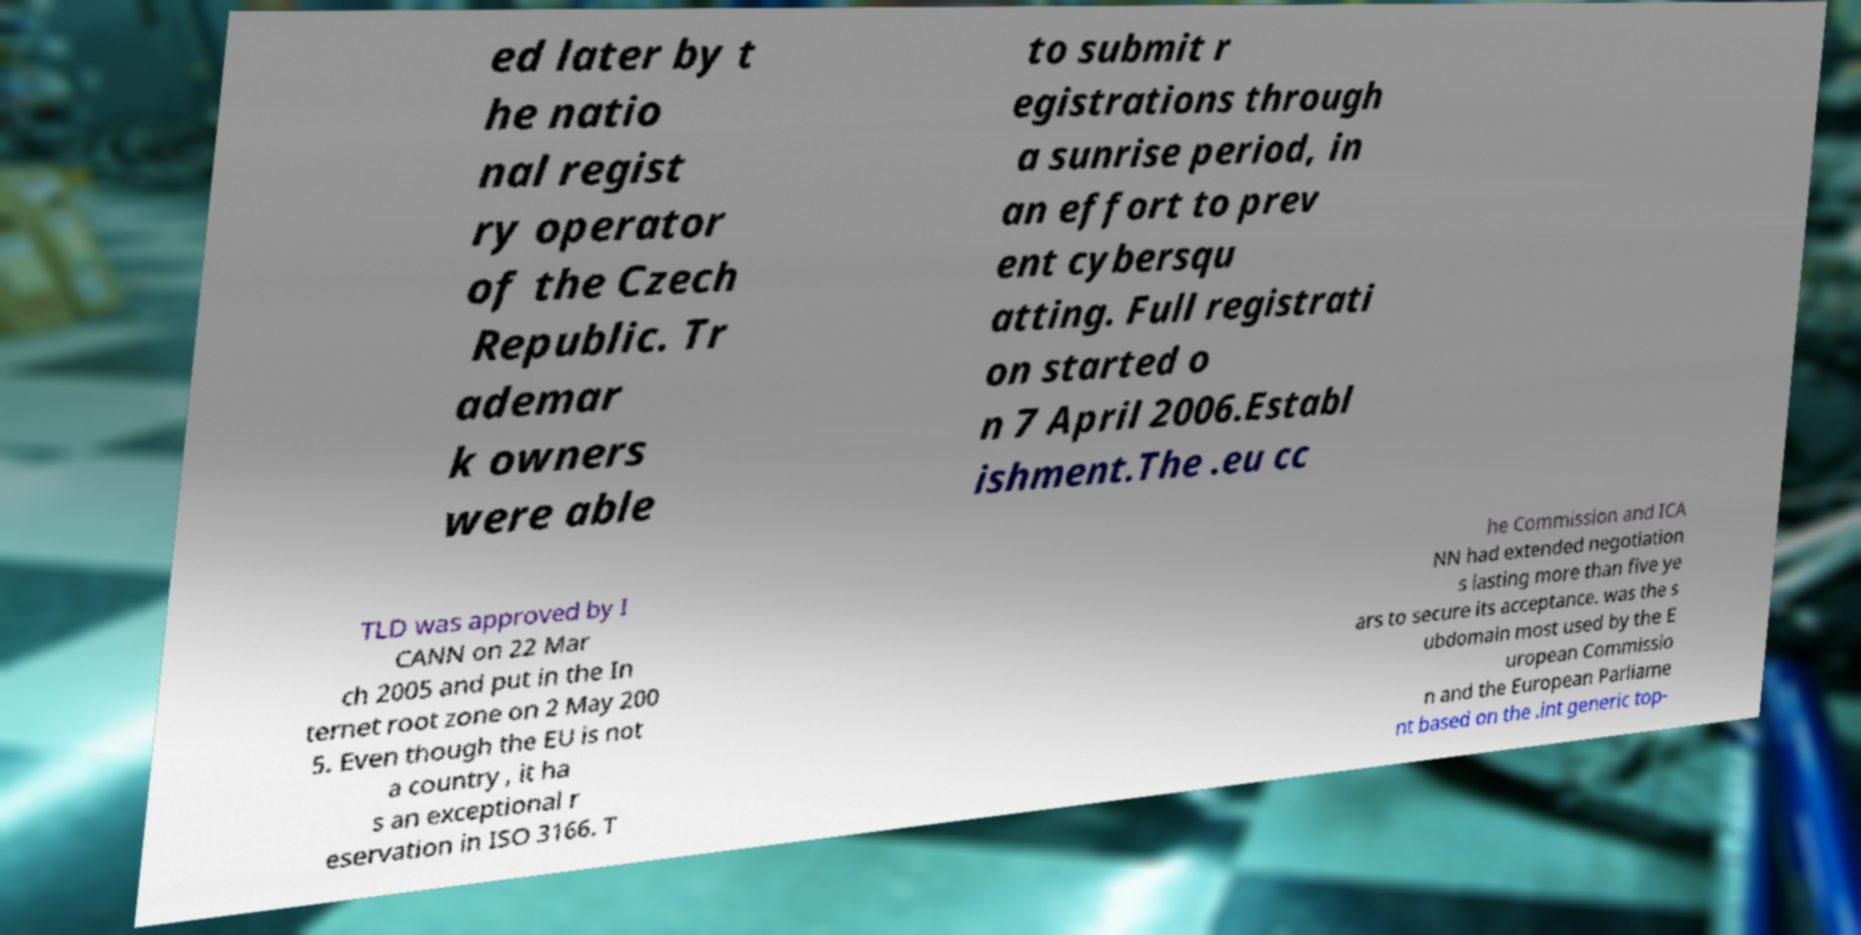I need the written content from this picture converted into text. Can you do that? ed later by t he natio nal regist ry operator of the Czech Republic. Tr ademar k owners were able to submit r egistrations through a sunrise period, in an effort to prev ent cybersqu atting. Full registrati on started o n 7 April 2006.Establ ishment.The .eu cc TLD was approved by I CANN on 22 Mar ch 2005 and put in the In ternet root zone on 2 May 200 5. Even though the EU is not a country , it ha s an exceptional r eservation in ISO 3166. T he Commission and ICA NN had extended negotiation s lasting more than five ye ars to secure its acceptance. was the s ubdomain most used by the E uropean Commissio n and the European Parliame nt based on the .int generic top- 